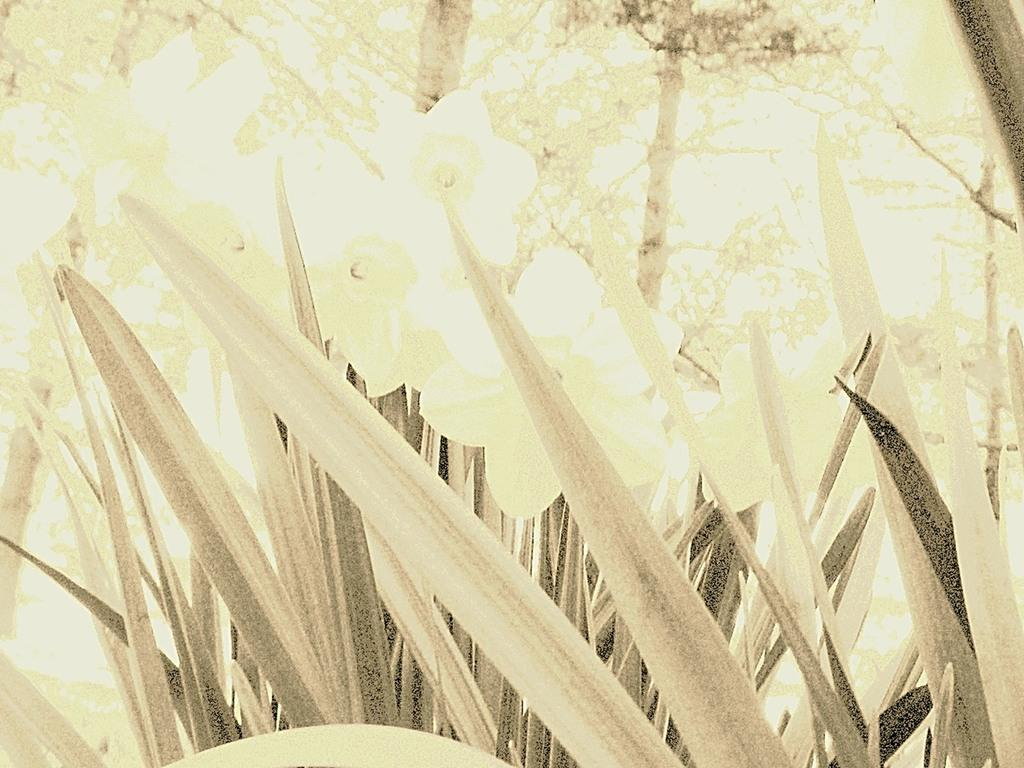What type of vegetation can be seen in the image? There are trees in the image. What other natural elements are present in the image? There is grass in the image. How many turkeys can be seen on the farm in the image? There is no farm or turkeys present in the image; it only features trees and grass. What is the height of the drop from the tree in the image? There is no indication of a drop or a specific tree in the image, so it cannot be determined. 